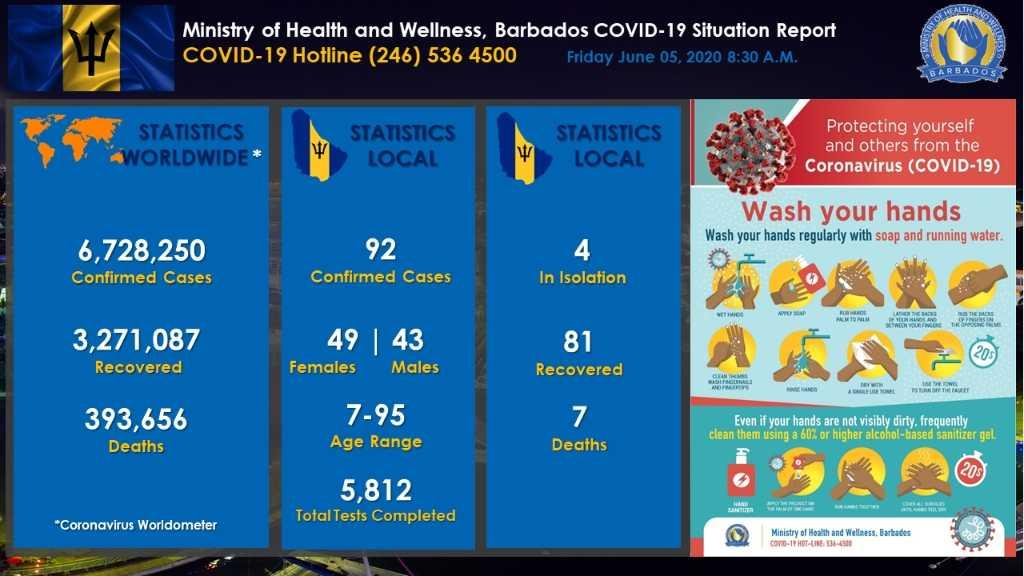Mention a couple of crucial points in this snapshot. There is a discrepancy between the number of deaths and the number of recovered cases locally, with 88 reported deaths and X recovered cases. Women are more infected locally than men. There are currently 11 confirmed cases and 11 recovered cases locally. There are 9 steps in the 20s hand washing process. The number of infected cases among men and women is 6.. 